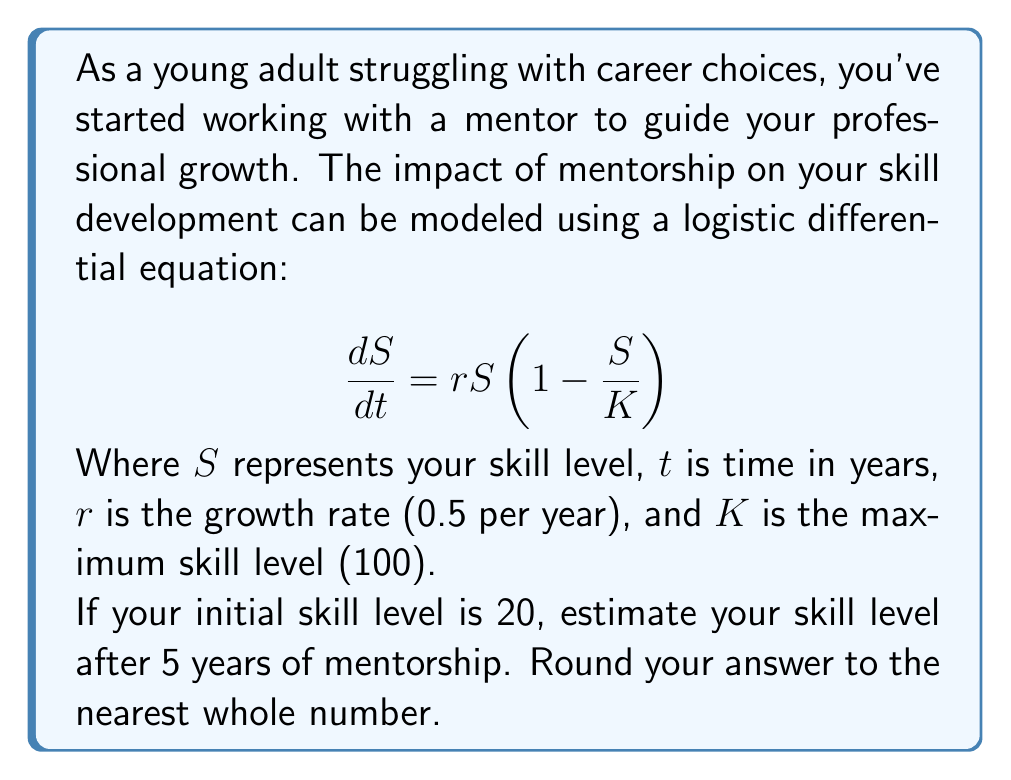Show me your answer to this math problem. To solve this problem, we need to use the solution to the logistic differential equation:

$$S(t) = \frac{K}{1 + (\frac{K}{S_0} - 1)e^{-rt}}$$

Where:
$S(t)$ is the skill level at time $t$
$K = 100$ (maximum skill level)
$S_0 = 20$ (initial skill level)
$r = 0.5$ (growth rate per year)
$t = 5$ (years of mentorship)

Let's substitute these values into the equation:

$$S(5) = \frac{100}{1 + (\frac{100}{20} - 1)e^{-0.5 \times 5}}$$

Now, let's solve this step-by-step:

1) First, simplify the fraction inside the parentheses:
   $$S(5) = \frac{100}{1 + (5 - 1)e^{-2.5}}$$

2) Simplify further:
   $$S(5) = \frac{100}{1 + 4e^{-2.5}}$$

3) Calculate $e^{-2.5}$:
   $$e^{-2.5} \approx 0.0821$$

4) Substitute this value:
   $$S(5) = \frac{100}{1 + 4(0.0821)} = \frac{100}{1 + 0.3284}$$

5) Simplify:
   $$S(5) = \frac{100}{1.3284} \approx 75.28$$

6) Rounding to the nearest whole number:
   $$S(5) \approx 75$$

Therefore, after 5 years of mentorship, your estimated skill level would be 75 out of 100.
Answer: 75 